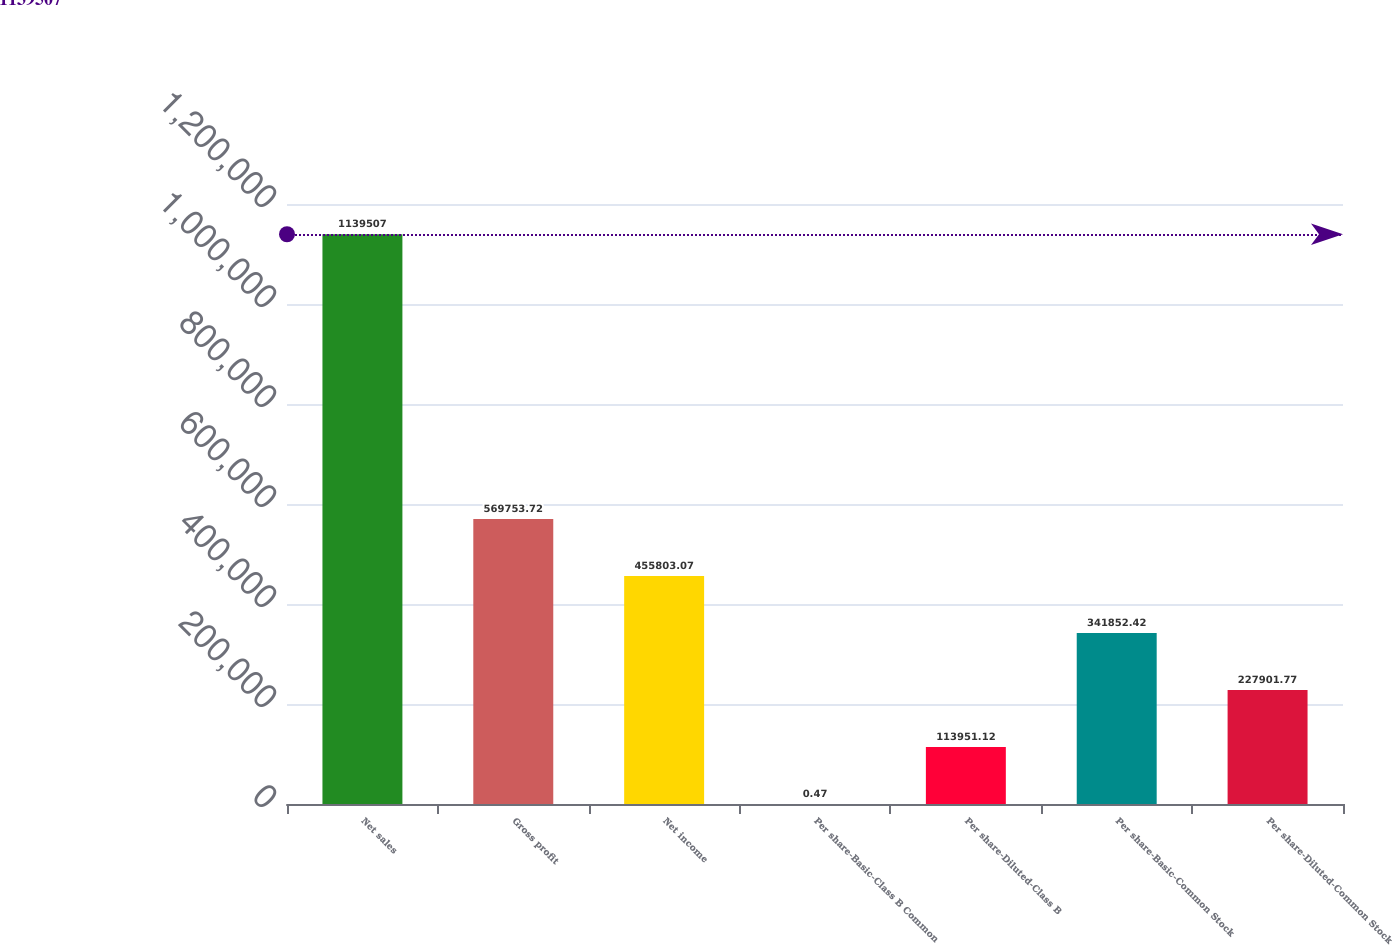<chart> <loc_0><loc_0><loc_500><loc_500><bar_chart><fcel>Net sales<fcel>Gross profit<fcel>Net income<fcel>Per share-Basic-Class B Common<fcel>Per share-Diluted-Class B<fcel>Per share-Basic-Common Stock<fcel>Per share-Diluted-Common Stock<nl><fcel>1.13951e+06<fcel>569754<fcel>455803<fcel>0.47<fcel>113951<fcel>341852<fcel>227902<nl></chart> 